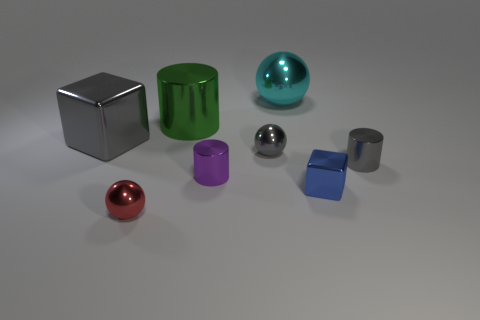There is another thing that is the same shape as the blue thing; what is its size?
Keep it short and to the point. Large. Does the large green shiny object that is behind the big gray thing have the same shape as the tiny purple object?
Offer a very short reply. Yes. What color is the block to the left of the cyan ball?
Your answer should be compact. Gray. How many other objects are the same size as the blue object?
Give a very brief answer. 4. Is there anything else that has the same shape as the blue metallic thing?
Your answer should be very brief. Yes. Are there the same number of big metallic cubes on the left side of the large gray cube and large purple balls?
Offer a very short reply. Yes. What number of big spheres have the same material as the tiny purple object?
Offer a very short reply. 1. What color is the large ball that is made of the same material as the gray block?
Keep it short and to the point. Cyan. Does the red thing have the same shape as the cyan shiny object?
Your answer should be compact. Yes. Are there any large gray shiny blocks that are in front of the cube in front of the gray shiny object on the left side of the tiny purple metal object?
Offer a very short reply. No. 